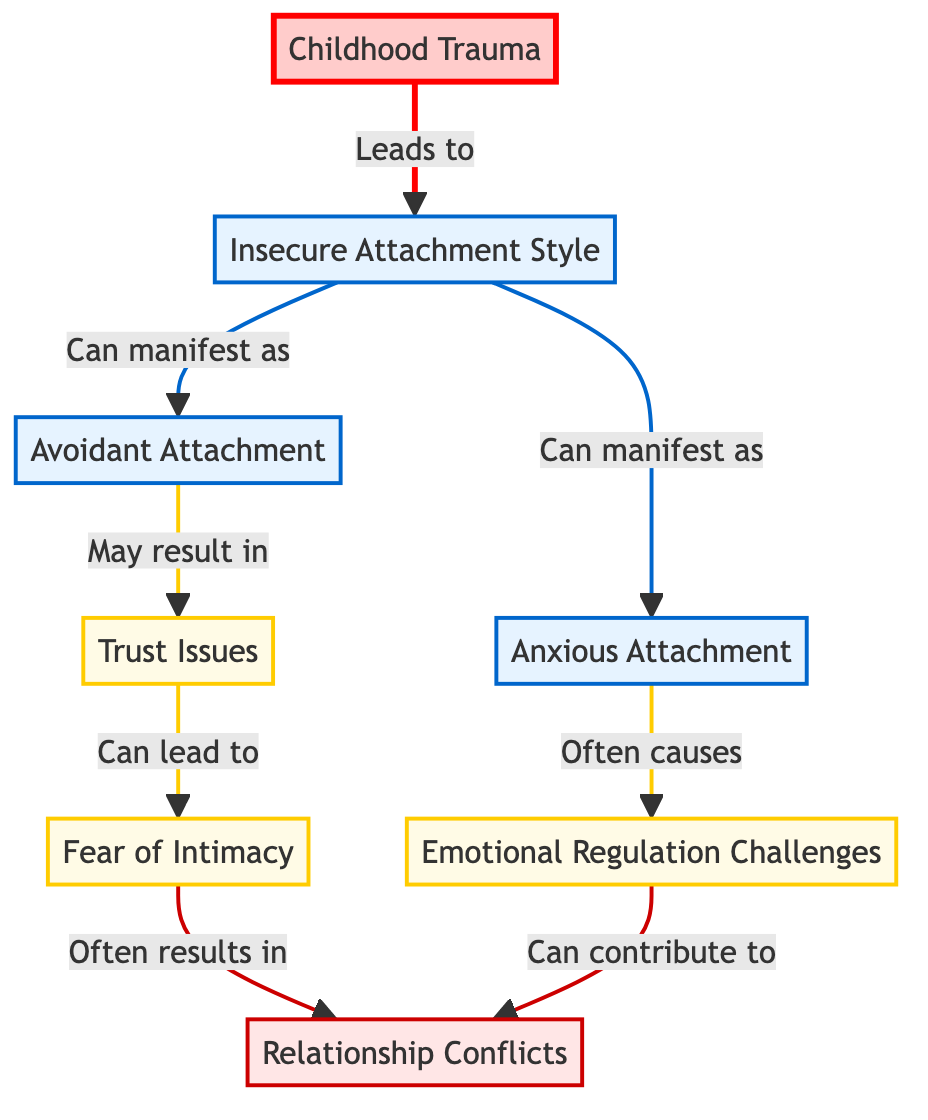What is the starting node in the diagram? The starting node is "Childhood Trauma," as it has arrows pointing towards "Insecure Attachment Style," indicating that it influences that node.
Answer: Childhood Trauma How many nodes are present in the diagram? The diagram lists 8 nodes related to childhood trauma and its effects on relationships, including "Childhood Trauma," "Insecure Attachment Style," "Avoidant Attachment," "Anxious Attachment," "Trust Issues," "Emotional Regulation Challenges," "Fear of Intimacy," and "Relationship Conflicts."
Answer: 8 Which node connects directly to "Trust Issues"? "Avoidant Attachment" connects directly to "Trust Issues," as indicated by the arrow pointing from "Avoidant Attachment" to "Trust Issues."
Answer: Avoidant Attachment What are the two types of insecure attachment styles shown in the diagram? The two types of insecure attachment styles depicted in the diagram are "Avoidant Attachment" and "Anxious Attachment," as both nodes flow from "Insecure Attachment Style."
Answer: Avoidant Attachment, Anxious Attachment Which nodes lead to "Relationship Conflicts"? "Fear of Intimacy" and "Emotional Regulation Challenges" both lead to "Relationship Conflicts," as shown by arrows pointing from these two nodes to "Relationship Conflicts."
Answer: Fear of Intimacy, Emotional Regulation Challenges What is the relationship between "Anxious Attachment" and "Emotional Regulation Challenges"? "Anxious Attachment" leads to "Emotional Regulation Challenges," indicating that experiencing an anxious attachment style often causes difficulties in regulating emotions.
Answer: Causes How does "Trust Issues" influence "Fear of Intimacy"? "Trust Issues" leads to "Fear of Intimacy," suggesting that having trust issues can result in a fear of becoming close or intimate with others.
Answer: Leads to Which node is the final outcome in the diagram? The final outcome in the diagram is "Relationship Conflicts," which is the end point influenced by other nodes like "Fear of Intimacy" and "Emotional Regulation Challenges."
Answer: Relationship Conflicts How many edges are in the diagram? The diagram contains 8 edges connecting the nodes, representing the relationships and influences among them.
Answer: 8 